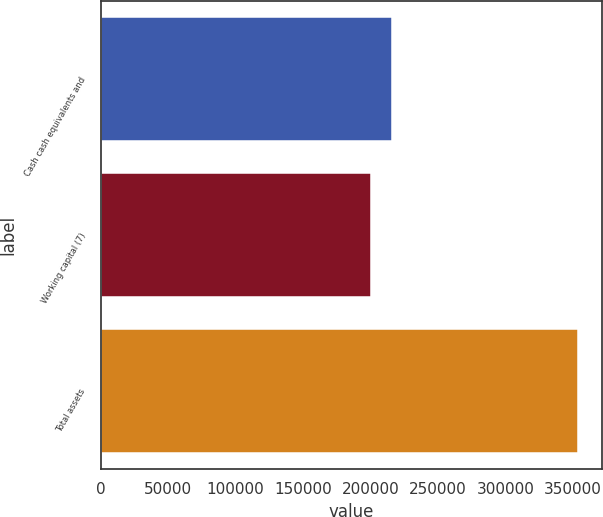Convert chart. <chart><loc_0><loc_0><loc_500><loc_500><bar_chart><fcel>Cash cash equivalents and<fcel>Working capital (7)<fcel>Total assets<nl><fcel>215556<fcel>200183<fcel>353910<nl></chart> 